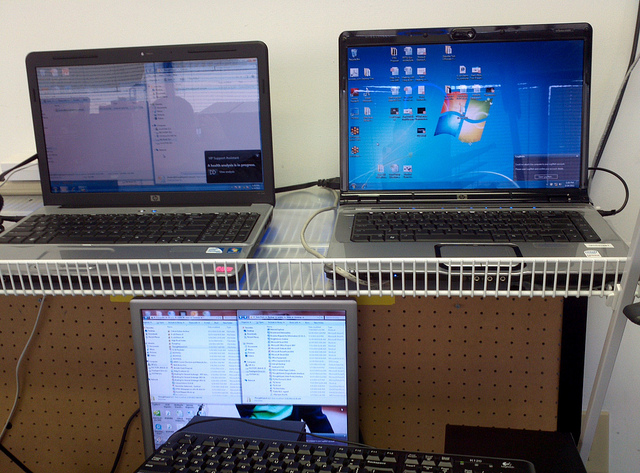Can you describe what's displayed on the screens? The top left screen shows a document or web page, possibly for research or reading. The top right screen displays a desktop with various icons, hinting at a typical working environment. The bottom screen seems to be displaying a list or directory structure, suggesting file management or coding work. 